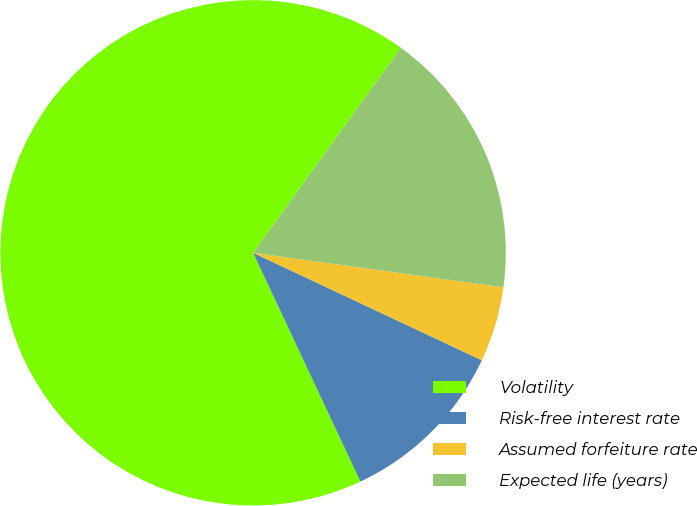Convert chart. <chart><loc_0><loc_0><loc_500><loc_500><pie_chart><fcel>Volatility<fcel>Risk-free interest rate<fcel>Assumed forfeiture rate<fcel>Expected life (years)<nl><fcel>66.92%<fcel>11.03%<fcel>4.81%<fcel>17.24%<nl></chart> 